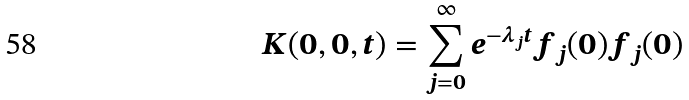<formula> <loc_0><loc_0><loc_500><loc_500>K ( 0 , 0 , t ) = \sum _ { j = 0 } ^ { \infty } e ^ { - \lambda _ { j } t } f _ { j } ( 0 ) f _ { j } ( 0 )</formula> 